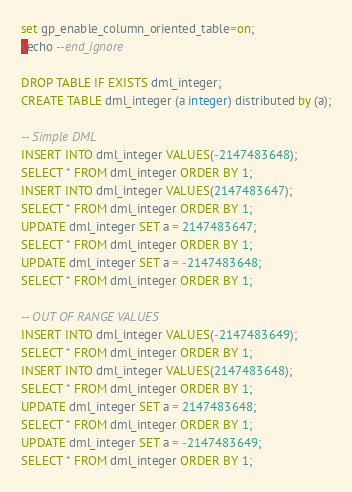Convert code to text. <code><loc_0><loc_0><loc_500><loc_500><_SQL_>set gp_enable_column_oriented_table=on;
\echo --end_ignore

DROP TABLE IF EXISTS dml_integer;
CREATE TABLE dml_integer (a integer) distributed by (a);

-- Simple DML
INSERT INTO dml_integer VALUES(-2147483648);
SELECT * FROM dml_integer ORDER BY 1;
INSERT INTO dml_integer VALUES(2147483647);
SELECT * FROM dml_integer ORDER BY 1;
UPDATE dml_integer SET a = 2147483647;
SELECT * FROM dml_integer ORDER BY 1;
UPDATE dml_integer SET a = -2147483648;
SELECT * FROM dml_integer ORDER BY 1;

-- OUT OF RANGE VALUES
INSERT INTO dml_integer VALUES(-2147483649);
SELECT * FROM dml_integer ORDER BY 1;
INSERT INTO dml_integer VALUES(2147483648);
SELECT * FROM dml_integer ORDER BY 1;
UPDATE dml_integer SET a = 2147483648;
SELECT * FROM dml_integer ORDER BY 1;
UPDATE dml_integer SET a = -2147483649;
SELECT * FROM dml_integer ORDER BY 1;

</code> 